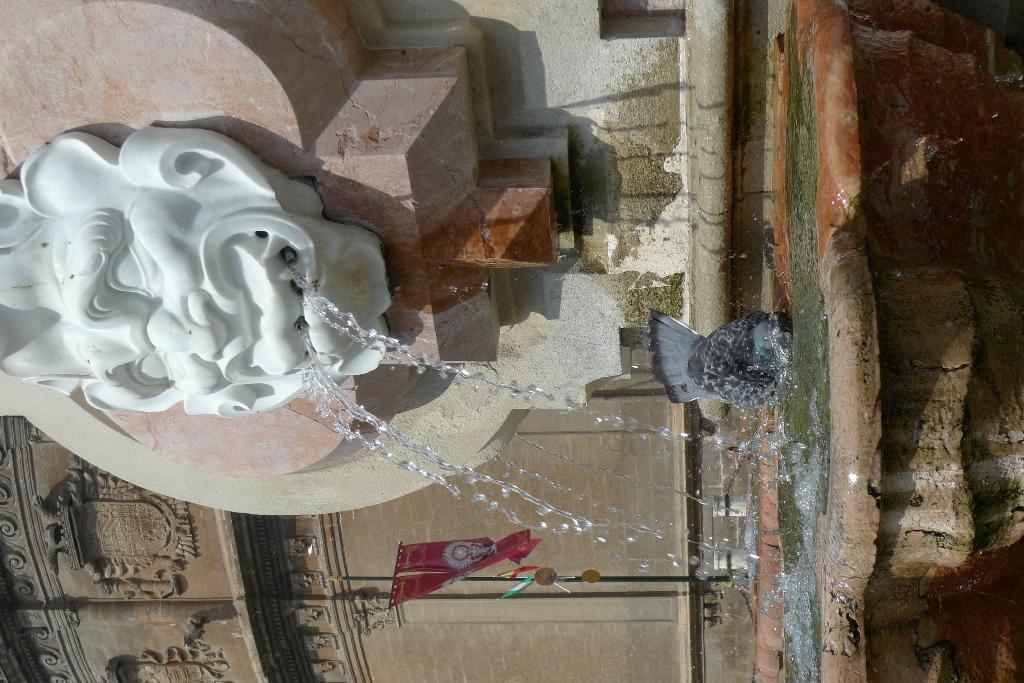Describe this image in one or two sentences. In this image there is a water fountain and art on the wall. 